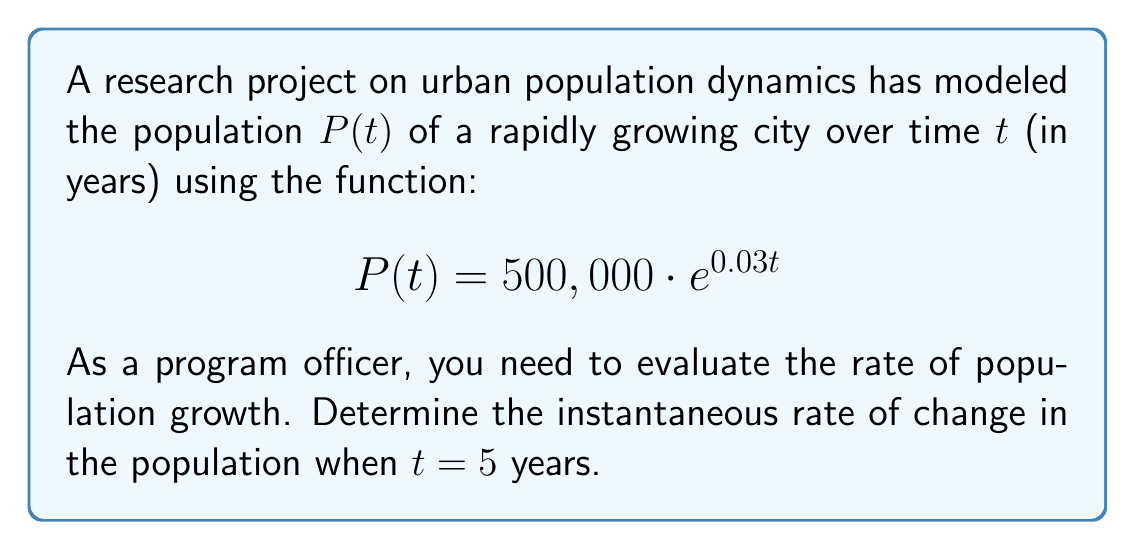Can you answer this question? To solve this problem, we need to use derivatives to find the instantaneous rate of change. Here's a step-by-step approach:

1) The given function for population growth is:
   $$P(t) = 500,000 \cdot e^{0.03t}$$

2) To find the rate of change, we need to find the derivative of $P(t)$ with respect to $t$. Using the chain rule:
   $$\frac{dP}{dt} = 500,000 \cdot 0.03 \cdot e^{0.03t}$$

3) Simplify:
   $$\frac{dP}{dt} = 15,000 \cdot e^{0.03t}$$

4) This derivative represents the instantaneous rate of change of the population at any time $t$.

5) To find the rate of change at $t = 5$ years, we substitute $t = 5$ into our derivative:
   $$\frac{dP}{dt}\bigg|_{t=5} = 15,000 \cdot e^{0.03 \cdot 5}$$

6) Calculate:
   $$\frac{dP}{dt}\bigg|_{t=5} = 15,000 \cdot e^{0.15} \approx 17,384.75$$

This result represents the number of people per year by which the population is increasing at $t = 5$ years.
Answer: The instantaneous rate of change in the population when $t = 5$ years is approximately 17,385 people per year. 